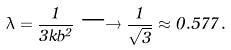<formula> <loc_0><loc_0><loc_500><loc_500>\lambda = \frac { 1 } { 3 k b ^ { 2 } } \longrightarrow \frac { 1 } { \sqrt { 3 } } \approx 0 . 5 7 7 \, .</formula> 